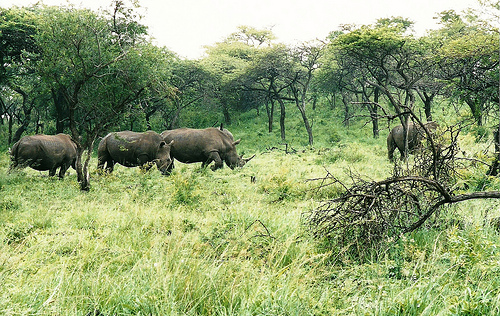<image>
Is there a horse next to the bike? No. The horse is not positioned next to the bike. They are located in different areas of the scene. Is the tree in front of the rhino? No. The tree is not in front of the rhino. The spatial positioning shows a different relationship between these objects. 